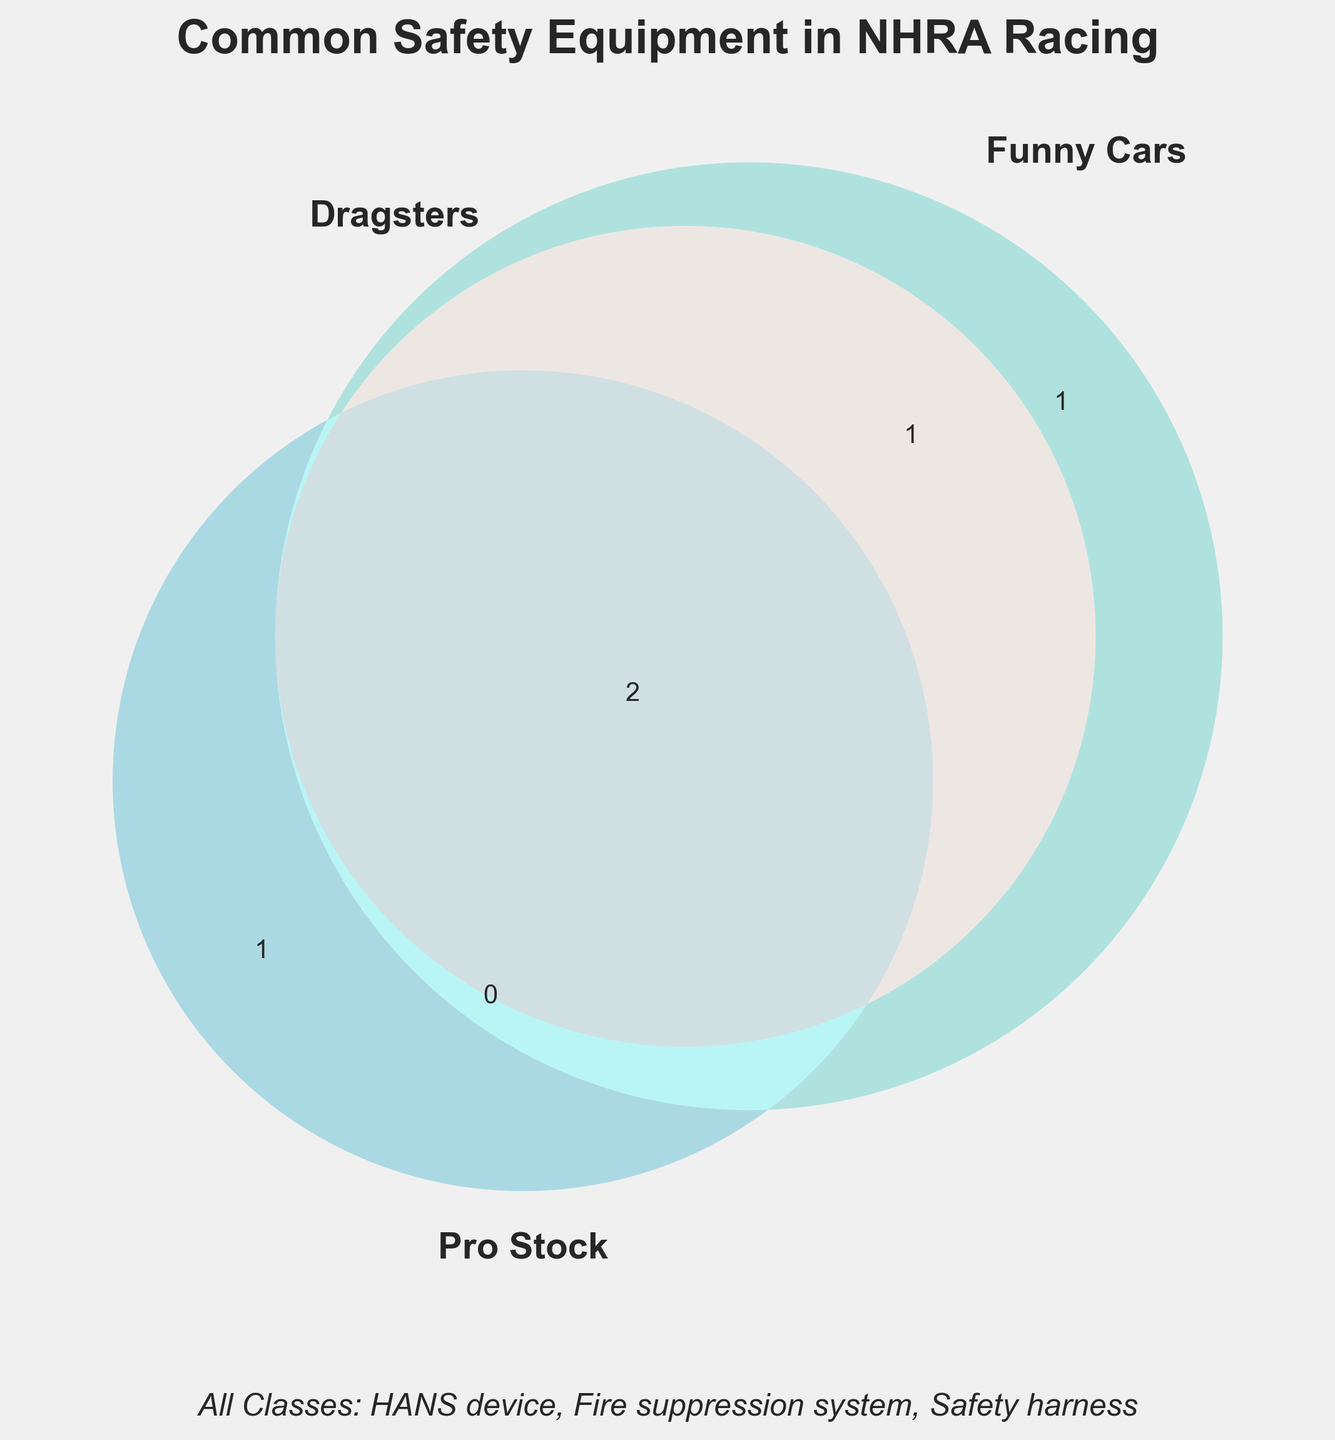What is the title of the Venn Diagram? The text at the top of the Venn Diagram indicates its title, which summarizes the focus of the chart.
Answer: Common Safety Equipment in NHRA Racing Which pieces of safety equipment are used only in Funny Cars? The section in the Venn Diagram exclusive to "Funny Cars" contains equipment unique to that class.
Answer: Escape hatch Which classes have a Fireproof suit as part of their safety equipment? By examining the intersecting regions, the Fireproof suit is present in the overlapping areas, shared by Dragsters, Funny Cars, and Pro Stock.
Answer: Dragsters, Funny Cars, Pro Stock How many pieces of safety equipment are common to both Dragsters and Pro Stock but not Funny Cars? Look at the overlapping section between Dragsters and Pro Stock that does not intersect with Funny Cars.
Answer: None Which classes use a Roll cage, and how can you tell? The Roll cage appears in the overlapping sections that contain Dragsters, Funny Cars, and Pro Stock.
Answer: Dragsters, Funny Cars, Pro Stock Which category has the most unique pieces of safety equipment? Check the sections of the Venn Diagram that do not overlap with others and count the elements in each.
Answer: Funny Cars (1 unique item) What safety equipment is common across all categories? The text at the bottom of the Venn Diagram and the central overlapping section point to equipment used across all classes.
Answer: HANS device, Fire suppression system, Safety harness Which safety equipment is shared by Dragsters and Funny Cars, but not Pro Stock? Find and read the overlapping section between Dragsters and Funny Cars that excludes Pro Stock.
Answer: Parachute Does Pro Stock have any safety equipment not shared with any other class? Any unique Pro Stock safety equipment would be in its exclusive section on the Venn Diagram.
Answer: Helmet How many pieces of safety equipment are listed for all classes together? Count all unique safety equipment mentioned across the entire Venn Diagram, including the common section at the bottom.
Answer: 11 